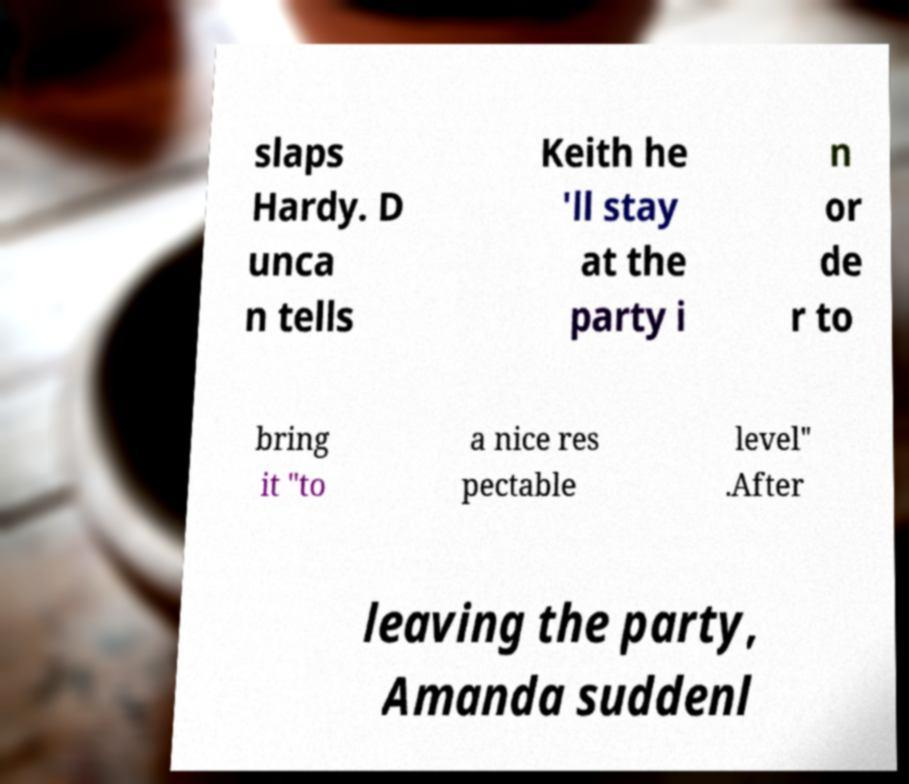Could you assist in decoding the text presented in this image and type it out clearly? slaps Hardy. D unca n tells Keith he 'll stay at the party i n or de r to bring it "to a nice res pectable level" .After leaving the party, Amanda suddenl 